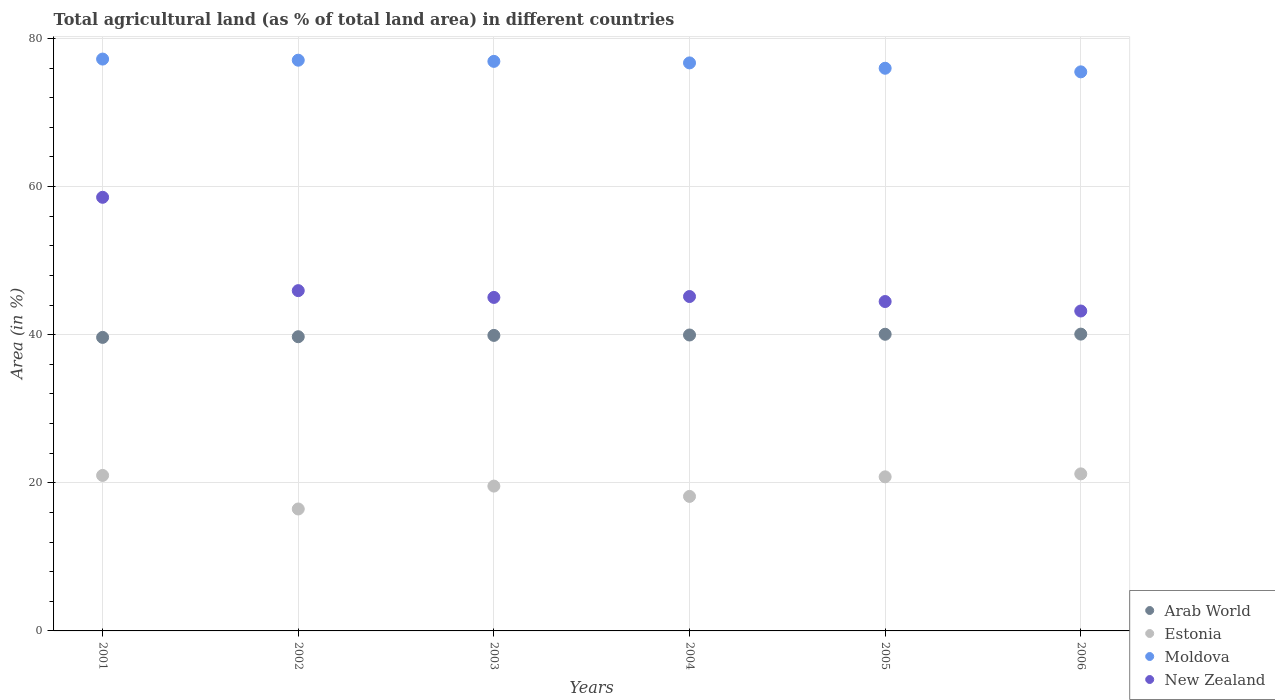How many different coloured dotlines are there?
Your answer should be very brief. 4. What is the percentage of agricultural land in New Zealand in 2003?
Offer a terse response. 45.03. Across all years, what is the maximum percentage of agricultural land in Arab World?
Provide a short and direct response. 40.08. Across all years, what is the minimum percentage of agricultural land in Estonia?
Keep it short and to the point. 16.47. In which year was the percentage of agricultural land in Arab World maximum?
Offer a very short reply. 2006. What is the total percentage of agricultural land in Estonia in the graph?
Your answer should be very brief. 117.2. What is the difference between the percentage of agricultural land in Arab World in 2003 and that in 2004?
Provide a short and direct response. -0.05. What is the difference between the percentage of agricultural land in Moldova in 2006 and the percentage of agricultural land in Arab World in 2004?
Give a very brief answer. 35.53. What is the average percentage of agricultural land in New Zealand per year?
Offer a very short reply. 47.06. In the year 2002, what is the difference between the percentage of agricultural land in Estonia and percentage of agricultural land in Arab World?
Provide a short and direct response. -23.26. What is the ratio of the percentage of agricultural land in Moldova in 2002 to that in 2005?
Keep it short and to the point. 1.01. Is the percentage of agricultural land in Estonia in 2001 less than that in 2002?
Offer a terse response. No. Is the difference between the percentage of agricultural land in Estonia in 2002 and 2006 greater than the difference between the percentage of agricultural land in Arab World in 2002 and 2006?
Make the answer very short. No. What is the difference between the highest and the second highest percentage of agricultural land in Moldova?
Ensure brevity in your answer.  0.15. What is the difference between the highest and the lowest percentage of agricultural land in Estonia?
Your response must be concise. 4.74. In how many years, is the percentage of agricultural land in Moldova greater than the average percentage of agricultural land in Moldova taken over all years?
Give a very brief answer. 4. Is the percentage of agricultural land in Arab World strictly less than the percentage of agricultural land in New Zealand over the years?
Offer a very short reply. Yes. How many dotlines are there?
Make the answer very short. 4. How many years are there in the graph?
Your answer should be very brief. 6. What is the difference between two consecutive major ticks on the Y-axis?
Provide a succinct answer. 20. Are the values on the major ticks of Y-axis written in scientific E-notation?
Ensure brevity in your answer.  No. Does the graph contain any zero values?
Provide a succinct answer. No. Does the graph contain grids?
Your answer should be compact. Yes. Where does the legend appear in the graph?
Offer a terse response. Bottom right. How many legend labels are there?
Provide a succinct answer. 4. What is the title of the graph?
Keep it short and to the point. Total agricultural land (as % of total land area) in different countries. Does "Malawi" appear as one of the legend labels in the graph?
Offer a very short reply. No. What is the label or title of the Y-axis?
Keep it short and to the point. Area (in %). What is the Area (in %) of Arab World in 2001?
Offer a terse response. 39.64. What is the Area (in %) in Estonia in 2001?
Provide a succinct answer. 21. What is the Area (in %) of Moldova in 2001?
Your response must be concise. 77.22. What is the Area (in %) of New Zealand in 2001?
Make the answer very short. 58.55. What is the Area (in %) in Arab World in 2002?
Keep it short and to the point. 39.73. What is the Area (in %) in Estonia in 2002?
Ensure brevity in your answer.  16.47. What is the Area (in %) of Moldova in 2002?
Your answer should be compact. 77.07. What is the Area (in %) of New Zealand in 2002?
Make the answer very short. 45.95. What is the Area (in %) of Arab World in 2003?
Give a very brief answer. 39.91. What is the Area (in %) in Estonia in 2003?
Provide a short and direct response. 19.56. What is the Area (in %) of Moldova in 2003?
Offer a very short reply. 76.91. What is the Area (in %) in New Zealand in 2003?
Provide a succinct answer. 45.03. What is the Area (in %) of Arab World in 2004?
Your answer should be compact. 39.96. What is the Area (in %) in Estonia in 2004?
Ensure brevity in your answer.  18.16. What is the Area (in %) of Moldova in 2004?
Your answer should be compact. 76.7. What is the Area (in %) in New Zealand in 2004?
Make the answer very short. 45.16. What is the Area (in %) of Arab World in 2005?
Your answer should be very brief. 40.06. What is the Area (in %) of Estonia in 2005?
Make the answer very short. 20.81. What is the Area (in %) in Moldova in 2005?
Provide a short and direct response. 75.98. What is the Area (in %) of New Zealand in 2005?
Provide a short and direct response. 44.48. What is the Area (in %) in Arab World in 2006?
Your response must be concise. 40.08. What is the Area (in %) of Estonia in 2006?
Offer a terse response. 21.21. What is the Area (in %) of Moldova in 2006?
Your answer should be very brief. 75.49. What is the Area (in %) in New Zealand in 2006?
Your answer should be very brief. 43.2. Across all years, what is the maximum Area (in %) of Arab World?
Offer a terse response. 40.08. Across all years, what is the maximum Area (in %) of Estonia?
Ensure brevity in your answer.  21.21. Across all years, what is the maximum Area (in %) of Moldova?
Offer a terse response. 77.22. Across all years, what is the maximum Area (in %) of New Zealand?
Provide a short and direct response. 58.55. Across all years, what is the minimum Area (in %) of Arab World?
Give a very brief answer. 39.64. Across all years, what is the minimum Area (in %) in Estonia?
Offer a terse response. 16.47. Across all years, what is the minimum Area (in %) of Moldova?
Ensure brevity in your answer.  75.49. Across all years, what is the minimum Area (in %) of New Zealand?
Ensure brevity in your answer.  43.2. What is the total Area (in %) of Arab World in the graph?
Your response must be concise. 239.37. What is the total Area (in %) in Estonia in the graph?
Your answer should be compact. 117.2. What is the total Area (in %) of Moldova in the graph?
Give a very brief answer. 459.38. What is the total Area (in %) of New Zealand in the graph?
Your answer should be very brief. 282.37. What is the difference between the Area (in %) in Arab World in 2001 and that in 2002?
Ensure brevity in your answer.  -0.09. What is the difference between the Area (in %) of Estonia in 2001 and that in 2002?
Ensure brevity in your answer.  4.53. What is the difference between the Area (in %) of Moldova in 2001 and that in 2002?
Provide a short and direct response. 0.15. What is the difference between the Area (in %) in New Zealand in 2001 and that in 2002?
Keep it short and to the point. 12.6. What is the difference between the Area (in %) of Arab World in 2001 and that in 2003?
Your response must be concise. -0.27. What is the difference between the Area (in %) in Estonia in 2001 and that in 2003?
Offer a terse response. 1.44. What is the difference between the Area (in %) in Moldova in 2001 and that in 2003?
Ensure brevity in your answer.  0.31. What is the difference between the Area (in %) in New Zealand in 2001 and that in 2003?
Your response must be concise. 13.52. What is the difference between the Area (in %) of Arab World in 2001 and that in 2004?
Offer a very short reply. -0.32. What is the difference between the Area (in %) of Estonia in 2001 and that in 2004?
Provide a succinct answer. 2.83. What is the difference between the Area (in %) of Moldova in 2001 and that in 2004?
Offer a terse response. 0.52. What is the difference between the Area (in %) in New Zealand in 2001 and that in 2004?
Keep it short and to the point. 13.4. What is the difference between the Area (in %) in Arab World in 2001 and that in 2005?
Your answer should be very brief. -0.42. What is the difference between the Area (in %) in Estonia in 2001 and that in 2005?
Offer a very short reply. 0.19. What is the difference between the Area (in %) of Moldova in 2001 and that in 2005?
Your answer should be very brief. 1.24. What is the difference between the Area (in %) of New Zealand in 2001 and that in 2005?
Provide a succinct answer. 14.07. What is the difference between the Area (in %) in Arab World in 2001 and that in 2006?
Provide a succinct answer. -0.44. What is the difference between the Area (in %) of Estonia in 2001 and that in 2006?
Give a very brief answer. -0.21. What is the difference between the Area (in %) in Moldova in 2001 and that in 2006?
Offer a terse response. 1.73. What is the difference between the Area (in %) in New Zealand in 2001 and that in 2006?
Your answer should be very brief. 15.35. What is the difference between the Area (in %) in Arab World in 2002 and that in 2003?
Keep it short and to the point. -0.18. What is the difference between the Area (in %) in Estonia in 2002 and that in 2003?
Your answer should be very brief. -3.09. What is the difference between the Area (in %) in Moldova in 2002 and that in 2003?
Provide a succinct answer. 0.16. What is the difference between the Area (in %) in New Zealand in 2002 and that in 2003?
Keep it short and to the point. 0.92. What is the difference between the Area (in %) of Arab World in 2002 and that in 2004?
Offer a terse response. -0.23. What is the difference between the Area (in %) in Estonia in 2002 and that in 2004?
Make the answer very short. -1.7. What is the difference between the Area (in %) of Moldova in 2002 and that in 2004?
Make the answer very short. 0.36. What is the difference between the Area (in %) in New Zealand in 2002 and that in 2004?
Make the answer very short. 0.79. What is the difference between the Area (in %) of Arab World in 2002 and that in 2005?
Keep it short and to the point. -0.33. What is the difference between the Area (in %) of Estonia in 2002 and that in 2005?
Make the answer very short. -4.34. What is the difference between the Area (in %) in Moldova in 2002 and that in 2005?
Your answer should be compact. 1.09. What is the difference between the Area (in %) in New Zealand in 2002 and that in 2005?
Provide a succinct answer. 1.47. What is the difference between the Area (in %) of Arab World in 2002 and that in 2006?
Make the answer very short. -0.35. What is the difference between the Area (in %) in Estonia in 2002 and that in 2006?
Provide a succinct answer. -4.74. What is the difference between the Area (in %) of Moldova in 2002 and that in 2006?
Make the answer very short. 1.57. What is the difference between the Area (in %) of New Zealand in 2002 and that in 2006?
Make the answer very short. 2.75. What is the difference between the Area (in %) in Arab World in 2003 and that in 2004?
Keep it short and to the point. -0.05. What is the difference between the Area (in %) in Estonia in 2003 and that in 2004?
Give a very brief answer. 1.39. What is the difference between the Area (in %) in Moldova in 2003 and that in 2004?
Ensure brevity in your answer.  0.21. What is the difference between the Area (in %) in New Zealand in 2003 and that in 2004?
Provide a succinct answer. -0.12. What is the difference between the Area (in %) of Arab World in 2003 and that in 2005?
Provide a succinct answer. -0.15. What is the difference between the Area (in %) of Estonia in 2003 and that in 2005?
Your response must be concise. -1.25. What is the difference between the Area (in %) in Moldova in 2003 and that in 2005?
Your answer should be compact. 0.93. What is the difference between the Area (in %) of New Zealand in 2003 and that in 2005?
Your answer should be compact. 0.55. What is the difference between the Area (in %) in Arab World in 2003 and that in 2006?
Provide a short and direct response. -0.17. What is the difference between the Area (in %) in Estonia in 2003 and that in 2006?
Give a very brief answer. -1.65. What is the difference between the Area (in %) of Moldova in 2003 and that in 2006?
Give a very brief answer. 1.42. What is the difference between the Area (in %) in New Zealand in 2003 and that in 2006?
Provide a succinct answer. 1.83. What is the difference between the Area (in %) of Arab World in 2004 and that in 2005?
Provide a short and direct response. -0.1. What is the difference between the Area (in %) of Estonia in 2004 and that in 2005?
Keep it short and to the point. -2.64. What is the difference between the Area (in %) in Moldova in 2004 and that in 2005?
Provide a succinct answer. 0.72. What is the difference between the Area (in %) of New Zealand in 2004 and that in 2005?
Your answer should be compact. 0.68. What is the difference between the Area (in %) in Arab World in 2004 and that in 2006?
Ensure brevity in your answer.  -0.12. What is the difference between the Area (in %) in Estonia in 2004 and that in 2006?
Offer a terse response. -3.04. What is the difference between the Area (in %) of Moldova in 2004 and that in 2006?
Give a very brief answer. 1.21. What is the difference between the Area (in %) of New Zealand in 2004 and that in 2006?
Provide a short and direct response. 1.96. What is the difference between the Area (in %) in Arab World in 2005 and that in 2006?
Offer a terse response. -0.02. What is the difference between the Area (in %) of Estonia in 2005 and that in 2006?
Your answer should be compact. -0.4. What is the difference between the Area (in %) of Moldova in 2005 and that in 2006?
Ensure brevity in your answer.  0.49. What is the difference between the Area (in %) in New Zealand in 2005 and that in 2006?
Your answer should be compact. 1.28. What is the difference between the Area (in %) in Arab World in 2001 and the Area (in %) in Estonia in 2002?
Make the answer very short. 23.17. What is the difference between the Area (in %) in Arab World in 2001 and the Area (in %) in Moldova in 2002?
Keep it short and to the point. -37.43. What is the difference between the Area (in %) of Arab World in 2001 and the Area (in %) of New Zealand in 2002?
Give a very brief answer. -6.31. What is the difference between the Area (in %) in Estonia in 2001 and the Area (in %) in Moldova in 2002?
Your answer should be compact. -56.07. What is the difference between the Area (in %) of Estonia in 2001 and the Area (in %) of New Zealand in 2002?
Give a very brief answer. -24.95. What is the difference between the Area (in %) of Moldova in 2001 and the Area (in %) of New Zealand in 2002?
Your response must be concise. 31.27. What is the difference between the Area (in %) in Arab World in 2001 and the Area (in %) in Estonia in 2003?
Your answer should be compact. 20.08. What is the difference between the Area (in %) of Arab World in 2001 and the Area (in %) of Moldova in 2003?
Offer a terse response. -37.27. What is the difference between the Area (in %) of Arab World in 2001 and the Area (in %) of New Zealand in 2003?
Make the answer very short. -5.4. What is the difference between the Area (in %) of Estonia in 2001 and the Area (in %) of Moldova in 2003?
Make the answer very short. -55.91. What is the difference between the Area (in %) in Estonia in 2001 and the Area (in %) in New Zealand in 2003?
Offer a terse response. -24.04. What is the difference between the Area (in %) in Moldova in 2001 and the Area (in %) in New Zealand in 2003?
Keep it short and to the point. 32.19. What is the difference between the Area (in %) in Arab World in 2001 and the Area (in %) in Estonia in 2004?
Offer a terse response. 21.47. What is the difference between the Area (in %) of Arab World in 2001 and the Area (in %) of Moldova in 2004?
Your answer should be very brief. -37.07. What is the difference between the Area (in %) of Arab World in 2001 and the Area (in %) of New Zealand in 2004?
Keep it short and to the point. -5.52. What is the difference between the Area (in %) of Estonia in 2001 and the Area (in %) of Moldova in 2004?
Ensure brevity in your answer.  -55.71. What is the difference between the Area (in %) in Estonia in 2001 and the Area (in %) in New Zealand in 2004?
Ensure brevity in your answer.  -24.16. What is the difference between the Area (in %) in Moldova in 2001 and the Area (in %) in New Zealand in 2004?
Keep it short and to the point. 32.06. What is the difference between the Area (in %) of Arab World in 2001 and the Area (in %) of Estonia in 2005?
Ensure brevity in your answer.  18.83. What is the difference between the Area (in %) in Arab World in 2001 and the Area (in %) in Moldova in 2005?
Provide a succinct answer. -36.34. What is the difference between the Area (in %) of Arab World in 2001 and the Area (in %) of New Zealand in 2005?
Your answer should be very brief. -4.84. What is the difference between the Area (in %) of Estonia in 2001 and the Area (in %) of Moldova in 2005?
Make the answer very short. -54.98. What is the difference between the Area (in %) of Estonia in 2001 and the Area (in %) of New Zealand in 2005?
Offer a very short reply. -23.48. What is the difference between the Area (in %) in Moldova in 2001 and the Area (in %) in New Zealand in 2005?
Your response must be concise. 32.74. What is the difference between the Area (in %) of Arab World in 2001 and the Area (in %) of Estonia in 2006?
Your answer should be compact. 18.43. What is the difference between the Area (in %) of Arab World in 2001 and the Area (in %) of Moldova in 2006?
Offer a terse response. -35.86. What is the difference between the Area (in %) in Arab World in 2001 and the Area (in %) in New Zealand in 2006?
Provide a succinct answer. -3.56. What is the difference between the Area (in %) of Estonia in 2001 and the Area (in %) of Moldova in 2006?
Provide a succinct answer. -54.5. What is the difference between the Area (in %) of Estonia in 2001 and the Area (in %) of New Zealand in 2006?
Offer a very short reply. -22.2. What is the difference between the Area (in %) in Moldova in 2001 and the Area (in %) in New Zealand in 2006?
Your answer should be compact. 34.02. What is the difference between the Area (in %) of Arab World in 2002 and the Area (in %) of Estonia in 2003?
Ensure brevity in your answer.  20.17. What is the difference between the Area (in %) in Arab World in 2002 and the Area (in %) in Moldova in 2003?
Your response must be concise. -37.18. What is the difference between the Area (in %) of Arab World in 2002 and the Area (in %) of New Zealand in 2003?
Keep it short and to the point. -5.31. What is the difference between the Area (in %) of Estonia in 2002 and the Area (in %) of Moldova in 2003?
Offer a very short reply. -60.44. What is the difference between the Area (in %) in Estonia in 2002 and the Area (in %) in New Zealand in 2003?
Offer a very short reply. -28.57. What is the difference between the Area (in %) of Moldova in 2002 and the Area (in %) of New Zealand in 2003?
Keep it short and to the point. 32.03. What is the difference between the Area (in %) in Arab World in 2002 and the Area (in %) in Estonia in 2004?
Offer a terse response. 21.56. What is the difference between the Area (in %) in Arab World in 2002 and the Area (in %) in Moldova in 2004?
Your answer should be very brief. -36.98. What is the difference between the Area (in %) in Arab World in 2002 and the Area (in %) in New Zealand in 2004?
Offer a very short reply. -5.43. What is the difference between the Area (in %) in Estonia in 2002 and the Area (in %) in Moldova in 2004?
Your response must be concise. -60.24. What is the difference between the Area (in %) of Estonia in 2002 and the Area (in %) of New Zealand in 2004?
Your answer should be compact. -28.69. What is the difference between the Area (in %) of Moldova in 2002 and the Area (in %) of New Zealand in 2004?
Your response must be concise. 31.91. What is the difference between the Area (in %) of Arab World in 2002 and the Area (in %) of Estonia in 2005?
Ensure brevity in your answer.  18.92. What is the difference between the Area (in %) of Arab World in 2002 and the Area (in %) of Moldova in 2005?
Provide a short and direct response. -36.25. What is the difference between the Area (in %) of Arab World in 2002 and the Area (in %) of New Zealand in 2005?
Your answer should be compact. -4.75. What is the difference between the Area (in %) of Estonia in 2002 and the Area (in %) of Moldova in 2005?
Keep it short and to the point. -59.51. What is the difference between the Area (in %) in Estonia in 2002 and the Area (in %) in New Zealand in 2005?
Keep it short and to the point. -28.01. What is the difference between the Area (in %) of Moldova in 2002 and the Area (in %) of New Zealand in 2005?
Keep it short and to the point. 32.59. What is the difference between the Area (in %) of Arab World in 2002 and the Area (in %) of Estonia in 2006?
Offer a very short reply. 18.52. What is the difference between the Area (in %) of Arab World in 2002 and the Area (in %) of Moldova in 2006?
Your answer should be very brief. -35.77. What is the difference between the Area (in %) in Arab World in 2002 and the Area (in %) in New Zealand in 2006?
Keep it short and to the point. -3.47. What is the difference between the Area (in %) in Estonia in 2002 and the Area (in %) in Moldova in 2006?
Your response must be concise. -59.03. What is the difference between the Area (in %) in Estonia in 2002 and the Area (in %) in New Zealand in 2006?
Provide a succinct answer. -26.73. What is the difference between the Area (in %) in Moldova in 2002 and the Area (in %) in New Zealand in 2006?
Provide a short and direct response. 33.87. What is the difference between the Area (in %) of Arab World in 2003 and the Area (in %) of Estonia in 2004?
Make the answer very short. 21.74. What is the difference between the Area (in %) of Arab World in 2003 and the Area (in %) of Moldova in 2004?
Ensure brevity in your answer.  -36.8. What is the difference between the Area (in %) in Arab World in 2003 and the Area (in %) in New Zealand in 2004?
Your response must be concise. -5.25. What is the difference between the Area (in %) of Estonia in 2003 and the Area (in %) of Moldova in 2004?
Keep it short and to the point. -57.15. What is the difference between the Area (in %) of Estonia in 2003 and the Area (in %) of New Zealand in 2004?
Ensure brevity in your answer.  -25.6. What is the difference between the Area (in %) of Moldova in 2003 and the Area (in %) of New Zealand in 2004?
Ensure brevity in your answer.  31.75. What is the difference between the Area (in %) in Arab World in 2003 and the Area (in %) in Estonia in 2005?
Keep it short and to the point. 19.1. What is the difference between the Area (in %) in Arab World in 2003 and the Area (in %) in Moldova in 2005?
Your answer should be very brief. -36.07. What is the difference between the Area (in %) of Arab World in 2003 and the Area (in %) of New Zealand in 2005?
Give a very brief answer. -4.57. What is the difference between the Area (in %) of Estonia in 2003 and the Area (in %) of Moldova in 2005?
Your answer should be compact. -56.42. What is the difference between the Area (in %) in Estonia in 2003 and the Area (in %) in New Zealand in 2005?
Give a very brief answer. -24.92. What is the difference between the Area (in %) in Moldova in 2003 and the Area (in %) in New Zealand in 2005?
Give a very brief answer. 32.43. What is the difference between the Area (in %) in Arab World in 2003 and the Area (in %) in Estonia in 2006?
Make the answer very short. 18.7. What is the difference between the Area (in %) of Arab World in 2003 and the Area (in %) of Moldova in 2006?
Make the answer very short. -35.59. What is the difference between the Area (in %) of Arab World in 2003 and the Area (in %) of New Zealand in 2006?
Your answer should be very brief. -3.29. What is the difference between the Area (in %) in Estonia in 2003 and the Area (in %) in Moldova in 2006?
Offer a terse response. -55.94. What is the difference between the Area (in %) in Estonia in 2003 and the Area (in %) in New Zealand in 2006?
Give a very brief answer. -23.64. What is the difference between the Area (in %) in Moldova in 2003 and the Area (in %) in New Zealand in 2006?
Keep it short and to the point. 33.71. What is the difference between the Area (in %) of Arab World in 2004 and the Area (in %) of Estonia in 2005?
Give a very brief answer. 19.15. What is the difference between the Area (in %) in Arab World in 2004 and the Area (in %) in Moldova in 2005?
Your answer should be compact. -36.02. What is the difference between the Area (in %) in Arab World in 2004 and the Area (in %) in New Zealand in 2005?
Make the answer very short. -4.52. What is the difference between the Area (in %) in Estonia in 2004 and the Area (in %) in Moldova in 2005?
Your answer should be compact. -57.82. What is the difference between the Area (in %) in Estonia in 2004 and the Area (in %) in New Zealand in 2005?
Provide a succinct answer. -26.32. What is the difference between the Area (in %) in Moldova in 2004 and the Area (in %) in New Zealand in 2005?
Offer a terse response. 32.22. What is the difference between the Area (in %) of Arab World in 2004 and the Area (in %) of Estonia in 2006?
Ensure brevity in your answer.  18.75. What is the difference between the Area (in %) of Arab World in 2004 and the Area (in %) of Moldova in 2006?
Offer a very short reply. -35.53. What is the difference between the Area (in %) of Arab World in 2004 and the Area (in %) of New Zealand in 2006?
Your answer should be compact. -3.24. What is the difference between the Area (in %) in Estonia in 2004 and the Area (in %) in Moldova in 2006?
Provide a short and direct response. -57.33. What is the difference between the Area (in %) in Estonia in 2004 and the Area (in %) in New Zealand in 2006?
Your answer should be compact. -25.04. What is the difference between the Area (in %) of Moldova in 2004 and the Area (in %) of New Zealand in 2006?
Your answer should be very brief. 33.5. What is the difference between the Area (in %) in Arab World in 2005 and the Area (in %) in Estonia in 2006?
Your answer should be compact. 18.85. What is the difference between the Area (in %) of Arab World in 2005 and the Area (in %) of Moldova in 2006?
Ensure brevity in your answer.  -35.43. What is the difference between the Area (in %) of Arab World in 2005 and the Area (in %) of New Zealand in 2006?
Your answer should be very brief. -3.14. What is the difference between the Area (in %) in Estonia in 2005 and the Area (in %) in Moldova in 2006?
Your answer should be very brief. -54.69. What is the difference between the Area (in %) in Estonia in 2005 and the Area (in %) in New Zealand in 2006?
Give a very brief answer. -22.39. What is the difference between the Area (in %) in Moldova in 2005 and the Area (in %) in New Zealand in 2006?
Keep it short and to the point. 32.78. What is the average Area (in %) in Arab World per year?
Make the answer very short. 39.89. What is the average Area (in %) in Estonia per year?
Your response must be concise. 19.53. What is the average Area (in %) of Moldova per year?
Provide a succinct answer. 76.56. What is the average Area (in %) in New Zealand per year?
Your answer should be very brief. 47.06. In the year 2001, what is the difference between the Area (in %) of Arab World and Area (in %) of Estonia?
Give a very brief answer. 18.64. In the year 2001, what is the difference between the Area (in %) of Arab World and Area (in %) of Moldova?
Your answer should be compact. -37.58. In the year 2001, what is the difference between the Area (in %) of Arab World and Area (in %) of New Zealand?
Provide a short and direct response. -18.92. In the year 2001, what is the difference between the Area (in %) of Estonia and Area (in %) of Moldova?
Make the answer very short. -56.22. In the year 2001, what is the difference between the Area (in %) of Estonia and Area (in %) of New Zealand?
Keep it short and to the point. -37.56. In the year 2001, what is the difference between the Area (in %) of Moldova and Area (in %) of New Zealand?
Your answer should be compact. 18.67. In the year 2002, what is the difference between the Area (in %) in Arab World and Area (in %) in Estonia?
Your answer should be very brief. 23.26. In the year 2002, what is the difference between the Area (in %) of Arab World and Area (in %) of Moldova?
Your answer should be compact. -37.34. In the year 2002, what is the difference between the Area (in %) in Arab World and Area (in %) in New Zealand?
Your answer should be very brief. -6.22. In the year 2002, what is the difference between the Area (in %) in Estonia and Area (in %) in Moldova?
Offer a very short reply. -60.6. In the year 2002, what is the difference between the Area (in %) of Estonia and Area (in %) of New Zealand?
Provide a short and direct response. -29.48. In the year 2002, what is the difference between the Area (in %) of Moldova and Area (in %) of New Zealand?
Ensure brevity in your answer.  31.12. In the year 2003, what is the difference between the Area (in %) of Arab World and Area (in %) of Estonia?
Ensure brevity in your answer.  20.35. In the year 2003, what is the difference between the Area (in %) in Arab World and Area (in %) in Moldova?
Your answer should be compact. -37. In the year 2003, what is the difference between the Area (in %) in Arab World and Area (in %) in New Zealand?
Provide a short and direct response. -5.13. In the year 2003, what is the difference between the Area (in %) in Estonia and Area (in %) in Moldova?
Provide a short and direct response. -57.35. In the year 2003, what is the difference between the Area (in %) of Estonia and Area (in %) of New Zealand?
Keep it short and to the point. -25.48. In the year 2003, what is the difference between the Area (in %) of Moldova and Area (in %) of New Zealand?
Your answer should be very brief. 31.87. In the year 2004, what is the difference between the Area (in %) of Arab World and Area (in %) of Estonia?
Keep it short and to the point. 21.8. In the year 2004, what is the difference between the Area (in %) in Arab World and Area (in %) in Moldova?
Give a very brief answer. -36.74. In the year 2004, what is the difference between the Area (in %) of Arab World and Area (in %) of New Zealand?
Provide a short and direct response. -5.2. In the year 2004, what is the difference between the Area (in %) of Estonia and Area (in %) of Moldova?
Offer a very short reply. -58.54. In the year 2004, what is the difference between the Area (in %) of Estonia and Area (in %) of New Zealand?
Your answer should be very brief. -26.99. In the year 2004, what is the difference between the Area (in %) of Moldova and Area (in %) of New Zealand?
Make the answer very short. 31.55. In the year 2005, what is the difference between the Area (in %) of Arab World and Area (in %) of Estonia?
Make the answer very short. 19.25. In the year 2005, what is the difference between the Area (in %) of Arab World and Area (in %) of Moldova?
Make the answer very short. -35.92. In the year 2005, what is the difference between the Area (in %) in Arab World and Area (in %) in New Zealand?
Your response must be concise. -4.42. In the year 2005, what is the difference between the Area (in %) in Estonia and Area (in %) in Moldova?
Offer a terse response. -55.17. In the year 2005, what is the difference between the Area (in %) of Estonia and Area (in %) of New Zealand?
Your response must be concise. -23.67. In the year 2005, what is the difference between the Area (in %) of Moldova and Area (in %) of New Zealand?
Provide a succinct answer. 31.5. In the year 2006, what is the difference between the Area (in %) of Arab World and Area (in %) of Estonia?
Provide a short and direct response. 18.87. In the year 2006, what is the difference between the Area (in %) in Arab World and Area (in %) in Moldova?
Make the answer very short. -35.42. In the year 2006, what is the difference between the Area (in %) of Arab World and Area (in %) of New Zealand?
Your answer should be compact. -3.12. In the year 2006, what is the difference between the Area (in %) of Estonia and Area (in %) of Moldova?
Offer a very short reply. -54.29. In the year 2006, what is the difference between the Area (in %) in Estonia and Area (in %) in New Zealand?
Your answer should be compact. -21.99. In the year 2006, what is the difference between the Area (in %) in Moldova and Area (in %) in New Zealand?
Provide a short and direct response. 32.29. What is the ratio of the Area (in %) in Arab World in 2001 to that in 2002?
Your response must be concise. 1. What is the ratio of the Area (in %) of Estonia in 2001 to that in 2002?
Your response must be concise. 1.28. What is the ratio of the Area (in %) of New Zealand in 2001 to that in 2002?
Your answer should be compact. 1.27. What is the ratio of the Area (in %) of Estonia in 2001 to that in 2003?
Your answer should be very brief. 1.07. What is the ratio of the Area (in %) of New Zealand in 2001 to that in 2003?
Keep it short and to the point. 1.3. What is the ratio of the Area (in %) of Estonia in 2001 to that in 2004?
Your answer should be very brief. 1.16. What is the ratio of the Area (in %) of Moldova in 2001 to that in 2004?
Offer a very short reply. 1.01. What is the ratio of the Area (in %) of New Zealand in 2001 to that in 2004?
Ensure brevity in your answer.  1.3. What is the ratio of the Area (in %) of Arab World in 2001 to that in 2005?
Provide a succinct answer. 0.99. What is the ratio of the Area (in %) in Estonia in 2001 to that in 2005?
Provide a succinct answer. 1.01. What is the ratio of the Area (in %) in Moldova in 2001 to that in 2005?
Ensure brevity in your answer.  1.02. What is the ratio of the Area (in %) in New Zealand in 2001 to that in 2005?
Ensure brevity in your answer.  1.32. What is the ratio of the Area (in %) in Arab World in 2001 to that in 2006?
Your response must be concise. 0.99. What is the ratio of the Area (in %) of Estonia in 2001 to that in 2006?
Your answer should be compact. 0.99. What is the ratio of the Area (in %) of Moldova in 2001 to that in 2006?
Provide a short and direct response. 1.02. What is the ratio of the Area (in %) of New Zealand in 2001 to that in 2006?
Offer a very short reply. 1.36. What is the ratio of the Area (in %) in Arab World in 2002 to that in 2003?
Provide a short and direct response. 1. What is the ratio of the Area (in %) of Estonia in 2002 to that in 2003?
Your answer should be very brief. 0.84. What is the ratio of the Area (in %) in New Zealand in 2002 to that in 2003?
Ensure brevity in your answer.  1.02. What is the ratio of the Area (in %) in Estonia in 2002 to that in 2004?
Keep it short and to the point. 0.91. What is the ratio of the Area (in %) in New Zealand in 2002 to that in 2004?
Your answer should be compact. 1.02. What is the ratio of the Area (in %) of Estonia in 2002 to that in 2005?
Provide a short and direct response. 0.79. What is the ratio of the Area (in %) in Moldova in 2002 to that in 2005?
Make the answer very short. 1.01. What is the ratio of the Area (in %) in New Zealand in 2002 to that in 2005?
Give a very brief answer. 1.03. What is the ratio of the Area (in %) of Estonia in 2002 to that in 2006?
Offer a very short reply. 0.78. What is the ratio of the Area (in %) in Moldova in 2002 to that in 2006?
Provide a short and direct response. 1.02. What is the ratio of the Area (in %) of New Zealand in 2002 to that in 2006?
Ensure brevity in your answer.  1.06. What is the ratio of the Area (in %) of Arab World in 2003 to that in 2004?
Give a very brief answer. 1. What is the ratio of the Area (in %) in Estonia in 2003 to that in 2004?
Offer a terse response. 1.08. What is the ratio of the Area (in %) in New Zealand in 2003 to that in 2004?
Offer a terse response. 1. What is the ratio of the Area (in %) in Estonia in 2003 to that in 2005?
Your answer should be very brief. 0.94. What is the ratio of the Area (in %) of Moldova in 2003 to that in 2005?
Offer a terse response. 1.01. What is the ratio of the Area (in %) of New Zealand in 2003 to that in 2005?
Make the answer very short. 1.01. What is the ratio of the Area (in %) in Estonia in 2003 to that in 2006?
Make the answer very short. 0.92. What is the ratio of the Area (in %) in Moldova in 2003 to that in 2006?
Provide a short and direct response. 1.02. What is the ratio of the Area (in %) of New Zealand in 2003 to that in 2006?
Give a very brief answer. 1.04. What is the ratio of the Area (in %) in Estonia in 2004 to that in 2005?
Make the answer very short. 0.87. What is the ratio of the Area (in %) in Moldova in 2004 to that in 2005?
Your response must be concise. 1.01. What is the ratio of the Area (in %) of New Zealand in 2004 to that in 2005?
Give a very brief answer. 1.02. What is the ratio of the Area (in %) of Estonia in 2004 to that in 2006?
Provide a succinct answer. 0.86. What is the ratio of the Area (in %) in New Zealand in 2004 to that in 2006?
Keep it short and to the point. 1.05. What is the ratio of the Area (in %) of Arab World in 2005 to that in 2006?
Ensure brevity in your answer.  1. What is the ratio of the Area (in %) in Estonia in 2005 to that in 2006?
Make the answer very short. 0.98. What is the ratio of the Area (in %) of Moldova in 2005 to that in 2006?
Keep it short and to the point. 1.01. What is the ratio of the Area (in %) in New Zealand in 2005 to that in 2006?
Your answer should be compact. 1.03. What is the difference between the highest and the second highest Area (in %) in Arab World?
Keep it short and to the point. 0.02. What is the difference between the highest and the second highest Area (in %) in Estonia?
Make the answer very short. 0.21. What is the difference between the highest and the second highest Area (in %) of Moldova?
Offer a very short reply. 0.15. What is the difference between the highest and the second highest Area (in %) of New Zealand?
Your answer should be very brief. 12.6. What is the difference between the highest and the lowest Area (in %) of Arab World?
Give a very brief answer. 0.44. What is the difference between the highest and the lowest Area (in %) of Estonia?
Offer a terse response. 4.74. What is the difference between the highest and the lowest Area (in %) of Moldova?
Keep it short and to the point. 1.73. What is the difference between the highest and the lowest Area (in %) of New Zealand?
Your answer should be compact. 15.35. 